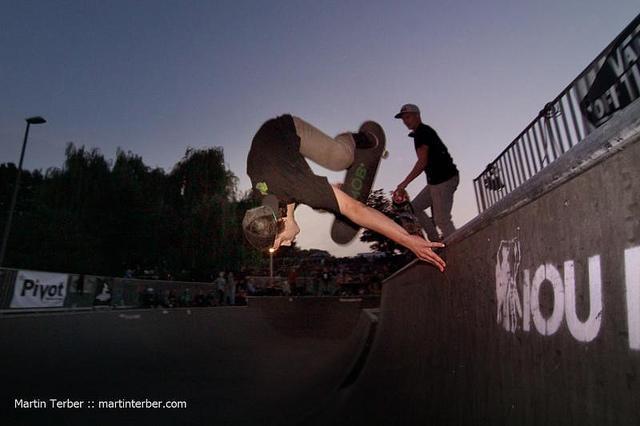How many skateboarders are in the photo?
Give a very brief answer. 2. How many people are visible?
Give a very brief answer. 2. 